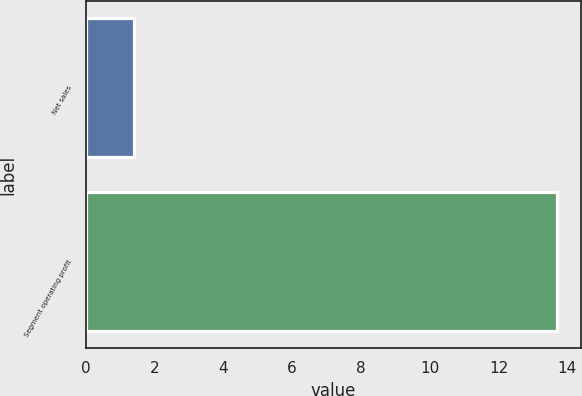Convert chart to OTSL. <chart><loc_0><loc_0><loc_500><loc_500><bar_chart><fcel>Net sales<fcel>Segment operating profit<nl><fcel>1.4<fcel>13.7<nl></chart> 